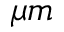Convert formula to latex. <formula><loc_0><loc_0><loc_500><loc_500>\mu m</formula> 